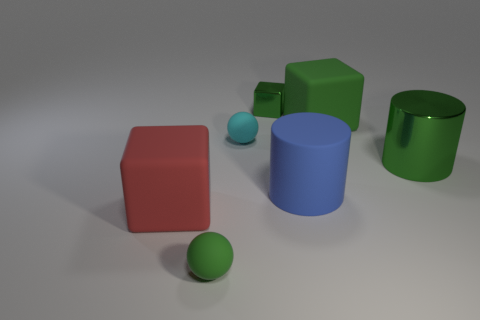Add 1 green rubber balls. How many objects exist? 8 Subtract all balls. How many objects are left? 5 Subtract all metallic cubes. Subtract all small cyan metal spheres. How many objects are left? 6 Add 3 large metallic objects. How many large metallic objects are left? 4 Add 6 tiny cyan matte spheres. How many tiny cyan matte spheres exist? 7 Subtract 0 gray cylinders. How many objects are left? 7 